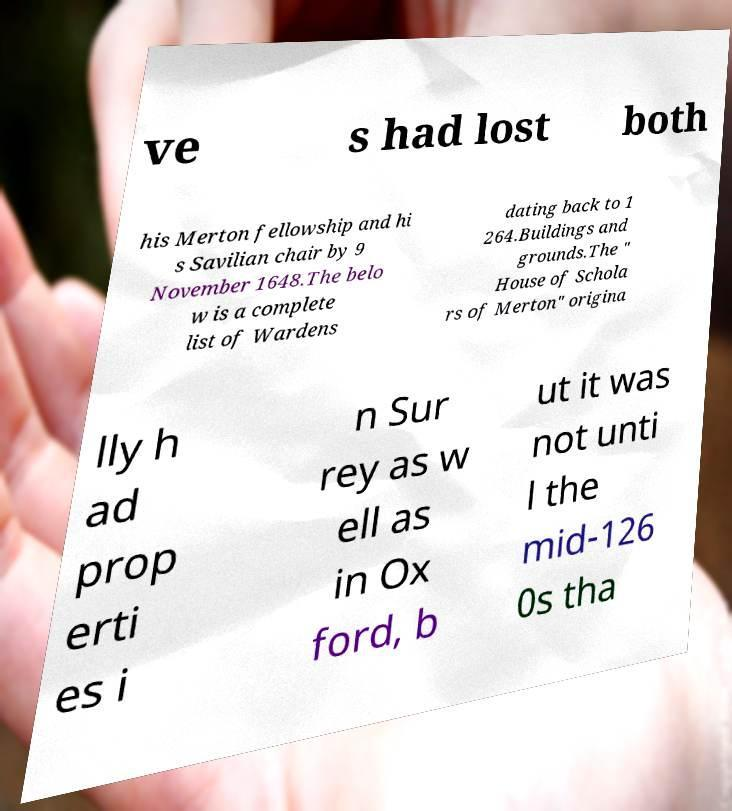Please read and relay the text visible in this image. What does it say? ve s had lost both his Merton fellowship and hi s Savilian chair by 9 November 1648.The belo w is a complete list of Wardens dating back to 1 264.Buildings and grounds.The " House of Schola rs of Merton" origina lly h ad prop erti es i n Sur rey as w ell as in Ox ford, b ut it was not unti l the mid-126 0s tha 